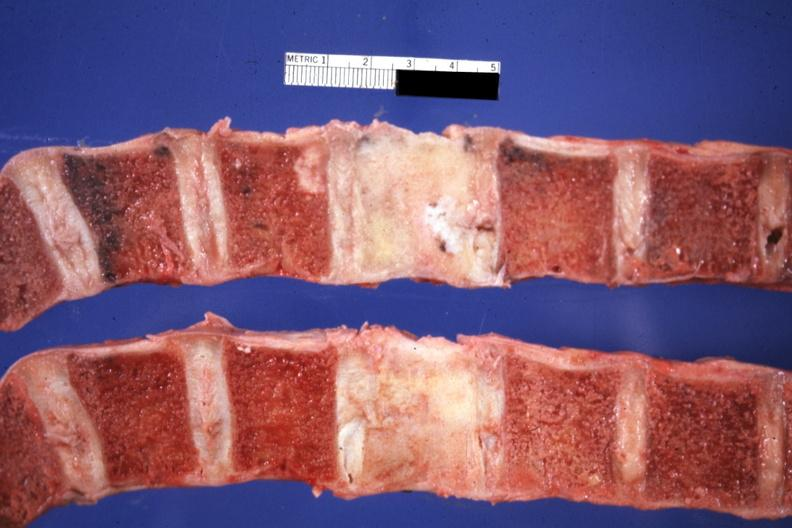does this image show sectioned typical primary is breast i think?
Answer the question using a single word or phrase. Yes 